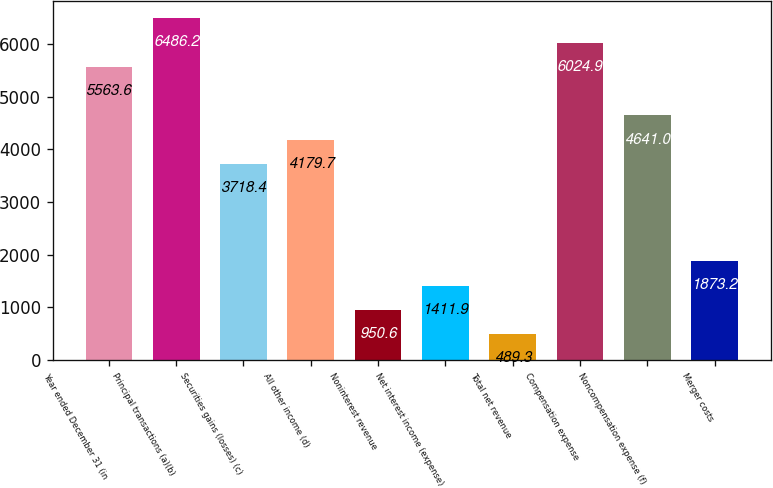Convert chart. <chart><loc_0><loc_0><loc_500><loc_500><bar_chart><fcel>Year ended December 31 (in<fcel>Principal transactions (a)(b)<fcel>Securities gains (losses) (c)<fcel>All other income (d)<fcel>Noninterest revenue<fcel>Net interest income (expense)<fcel>Total net revenue<fcel>Compensation expense<fcel>Noncompensation expense (f)<fcel>Merger costs<nl><fcel>5563.6<fcel>6486.2<fcel>3718.4<fcel>4179.7<fcel>950.6<fcel>1411.9<fcel>489.3<fcel>6024.9<fcel>4641<fcel>1873.2<nl></chart> 